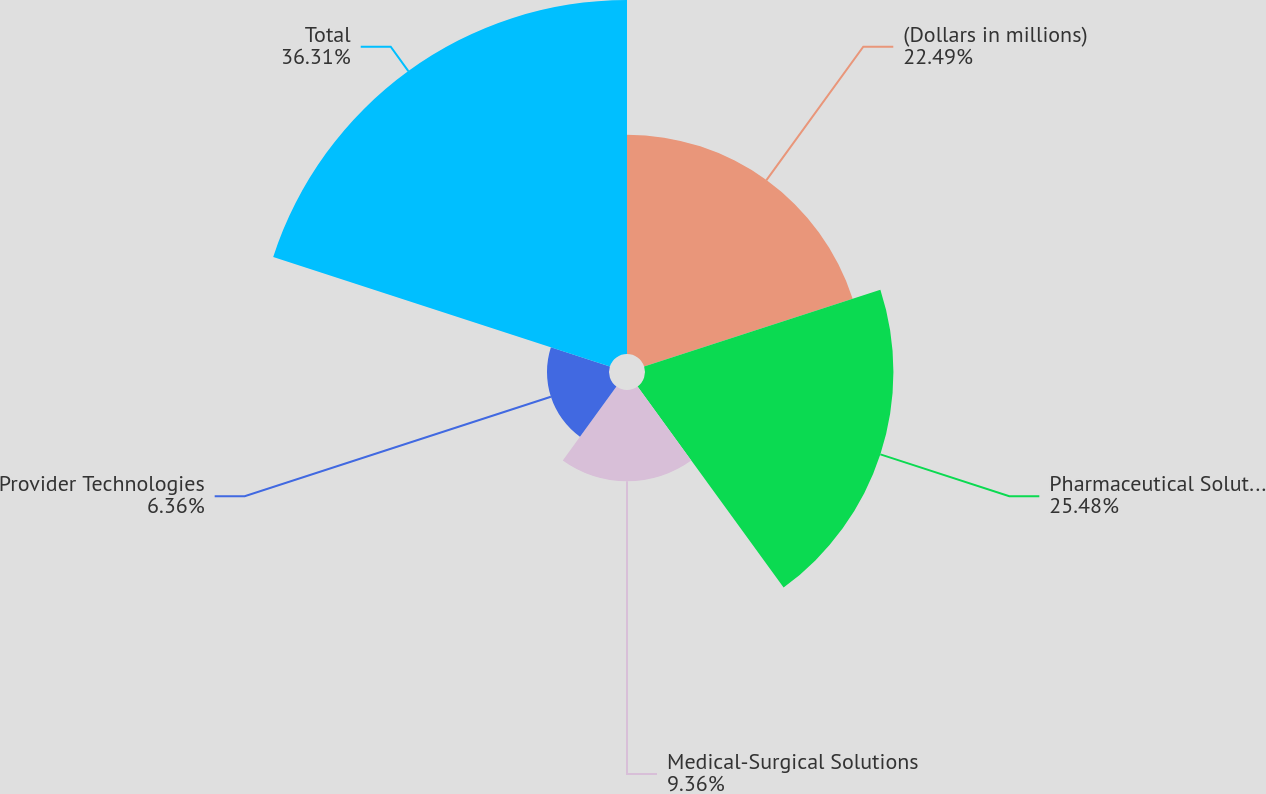Convert chart. <chart><loc_0><loc_0><loc_500><loc_500><pie_chart><fcel>(Dollars in millions)<fcel>Pharmaceutical Solutions<fcel>Medical-Surgical Solutions<fcel>Provider Technologies<fcel>Total<nl><fcel>22.49%<fcel>25.48%<fcel>9.36%<fcel>6.36%<fcel>36.31%<nl></chart> 